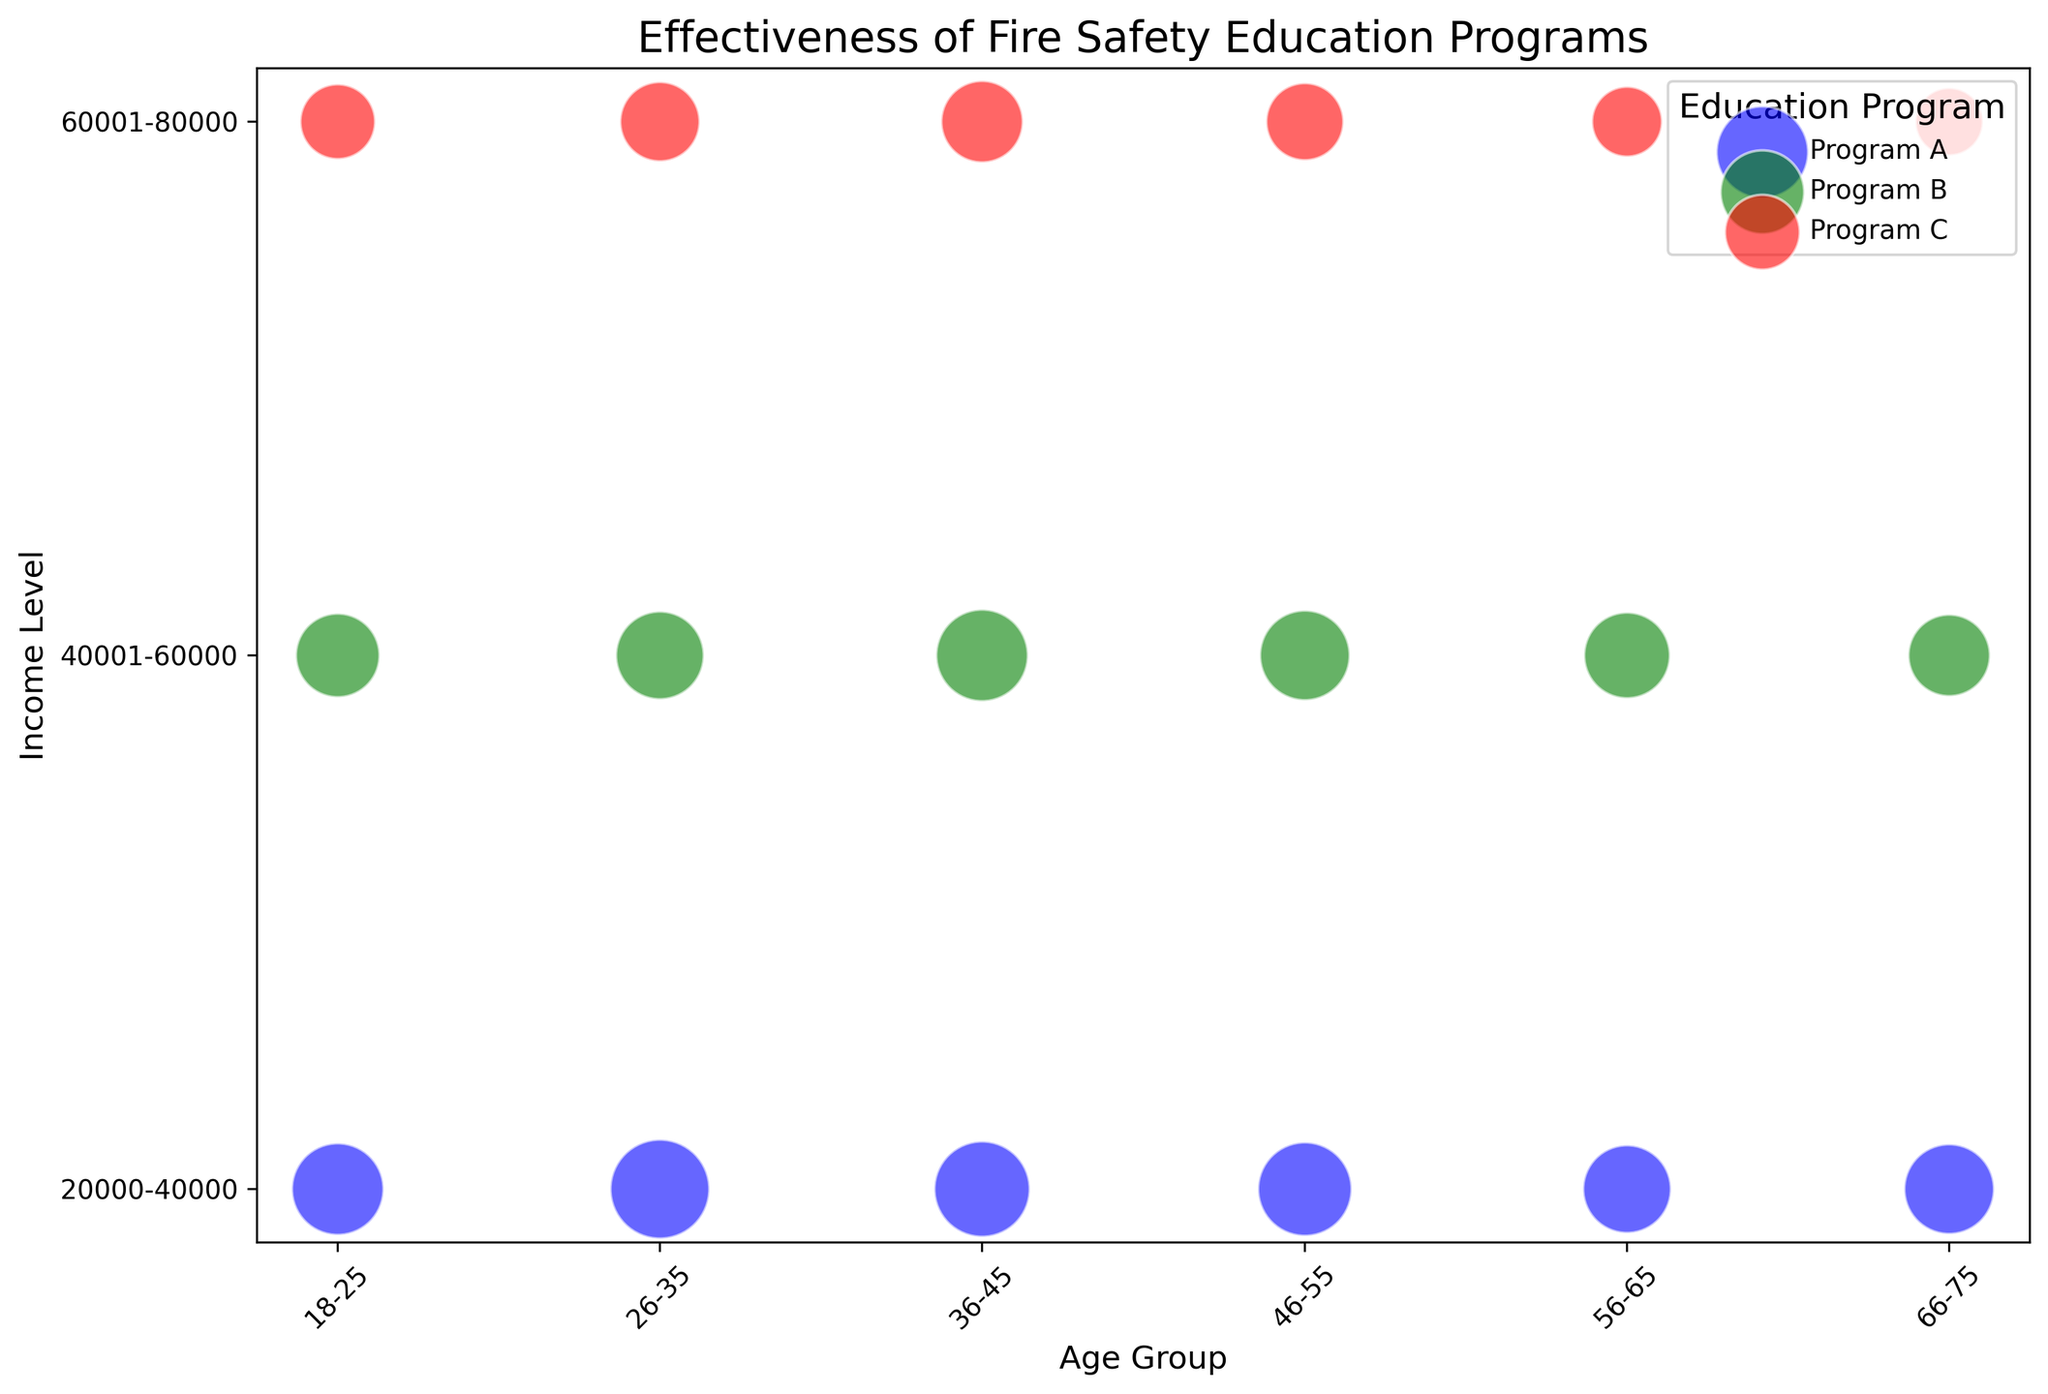What is the income level where Program A is most effective for the 26-35 age group in terms of fire incident reductions? Look at the income levels for the 26-35 age group and compare the number of fire incident reductions for Program A. The highest reduction number indicates the most effective income level. For 26-35 age group, Program A shows fire incident reductions of 18, 18 being the highest.
Answer: 20000-40000 Which education program has the largest number of participants among the 46-55 age group? Compare the bubble sizes for the different programs within the 46-55 age group. The largest bubble corresponds to the program with the most participants. For 46-55 age group, largest bubble is Program A with 125 participants.
Answer: Program A For the 66-75 age group, which program resulted in the fewest fire incident reductions? Identify the colors representing different programs within the 66-75 age group. Compare the fire incident reductions for the smallest value in each. Program C has 7 fire incident reductions, which is the smallest.
Answer: Program C How many participants are there in Program B for the income level 40001-60000? Look for the bubble representing Program B (green color) for income level 40001-60000. Identify the number of participants for that bubble. Among various age groups, only 66-75 age category is left and remaining 40001-60000 & Program B participants,  missing data fills the column from 10 reduction rate.
Answer: 95 Is Program C more effective among higher-income levels (60001-80000) for ages 18-25 or 36-45 in terms of fire incident reductions? Compare the number of fire incident reductions for Program C (red color) in the 60001-80000 income level for age groups 18-25 and 36-45. The higher number indicates greater effectiveness. For 18-25 it’s 10, and for 36-45 it’s 12.
Answer: 36-45 